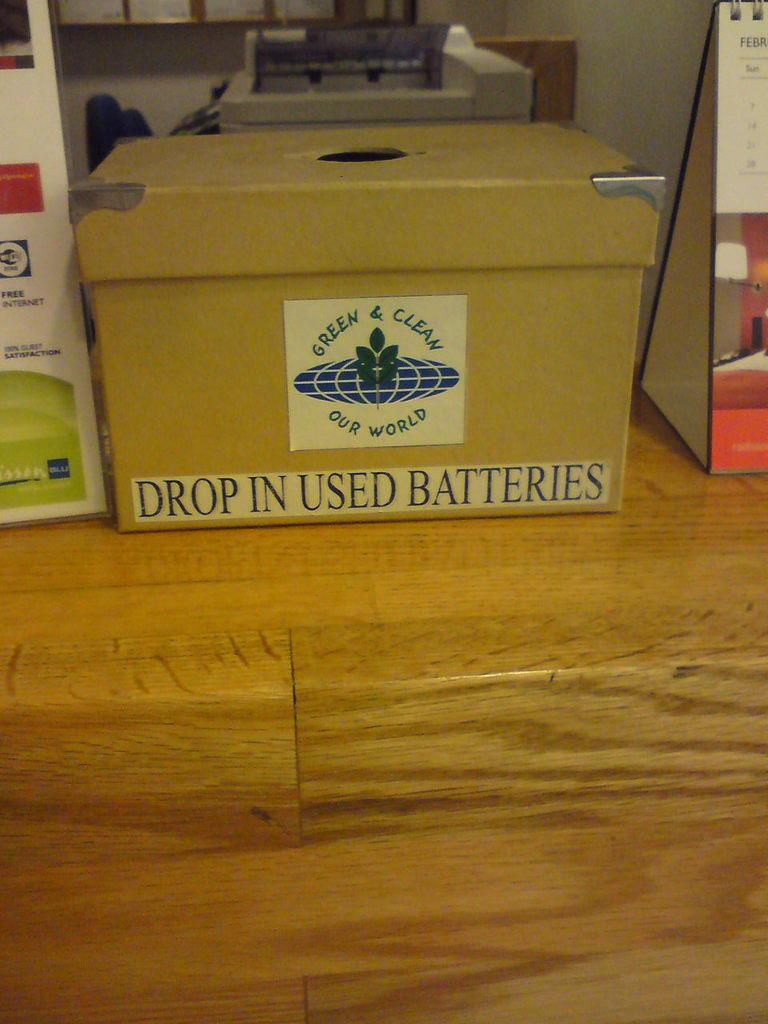<image>
Write a terse but informative summary of the picture. A box used for disposing of used batteries. 